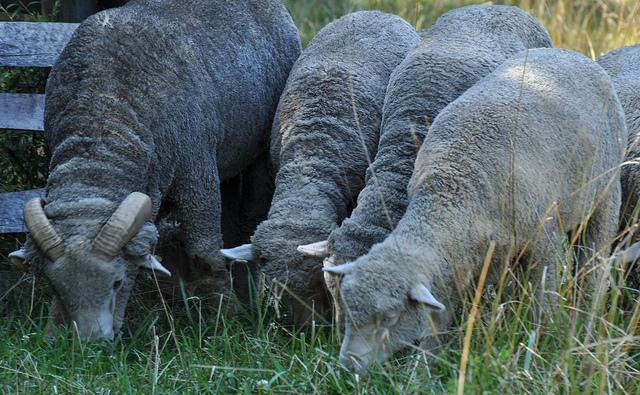A fleece is a kind of hair getting from which mammal?

Choices:
A) bear
B) goat
C) sheep
D) deer sheep 